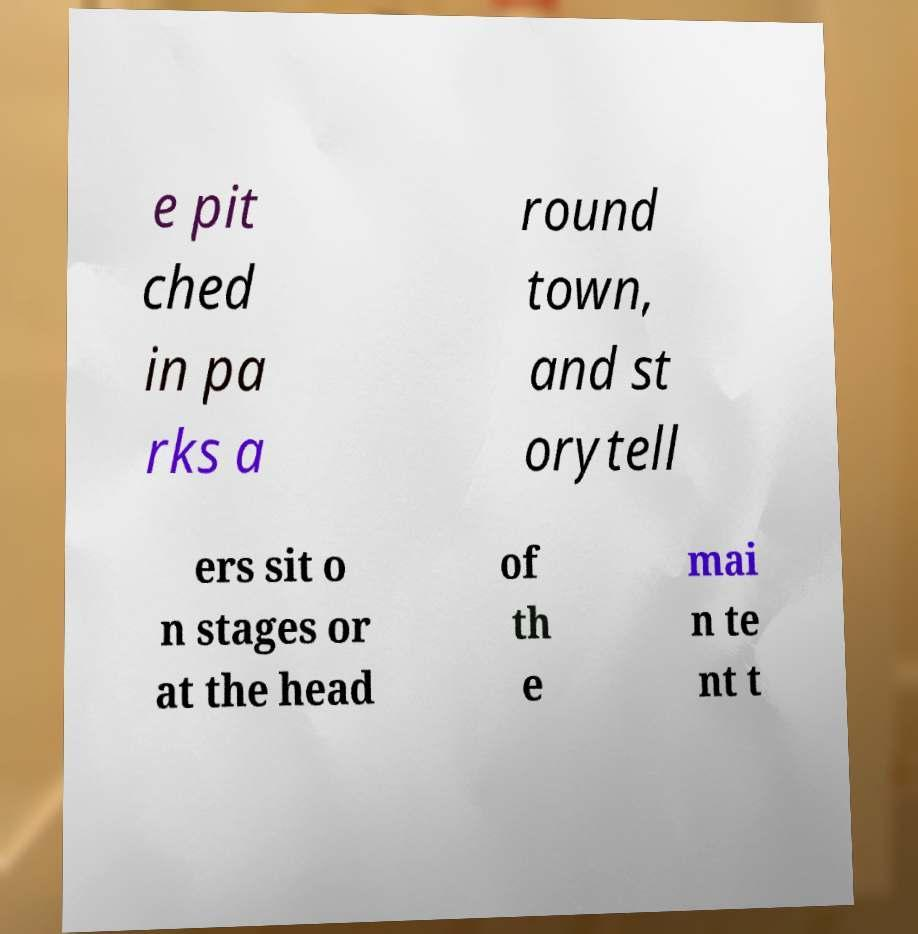Can you accurately transcribe the text from the provided image for me? e pit ched in pa rks a round town, and st orytell ers sit o n stages or at the head of th e mai n te nt t 